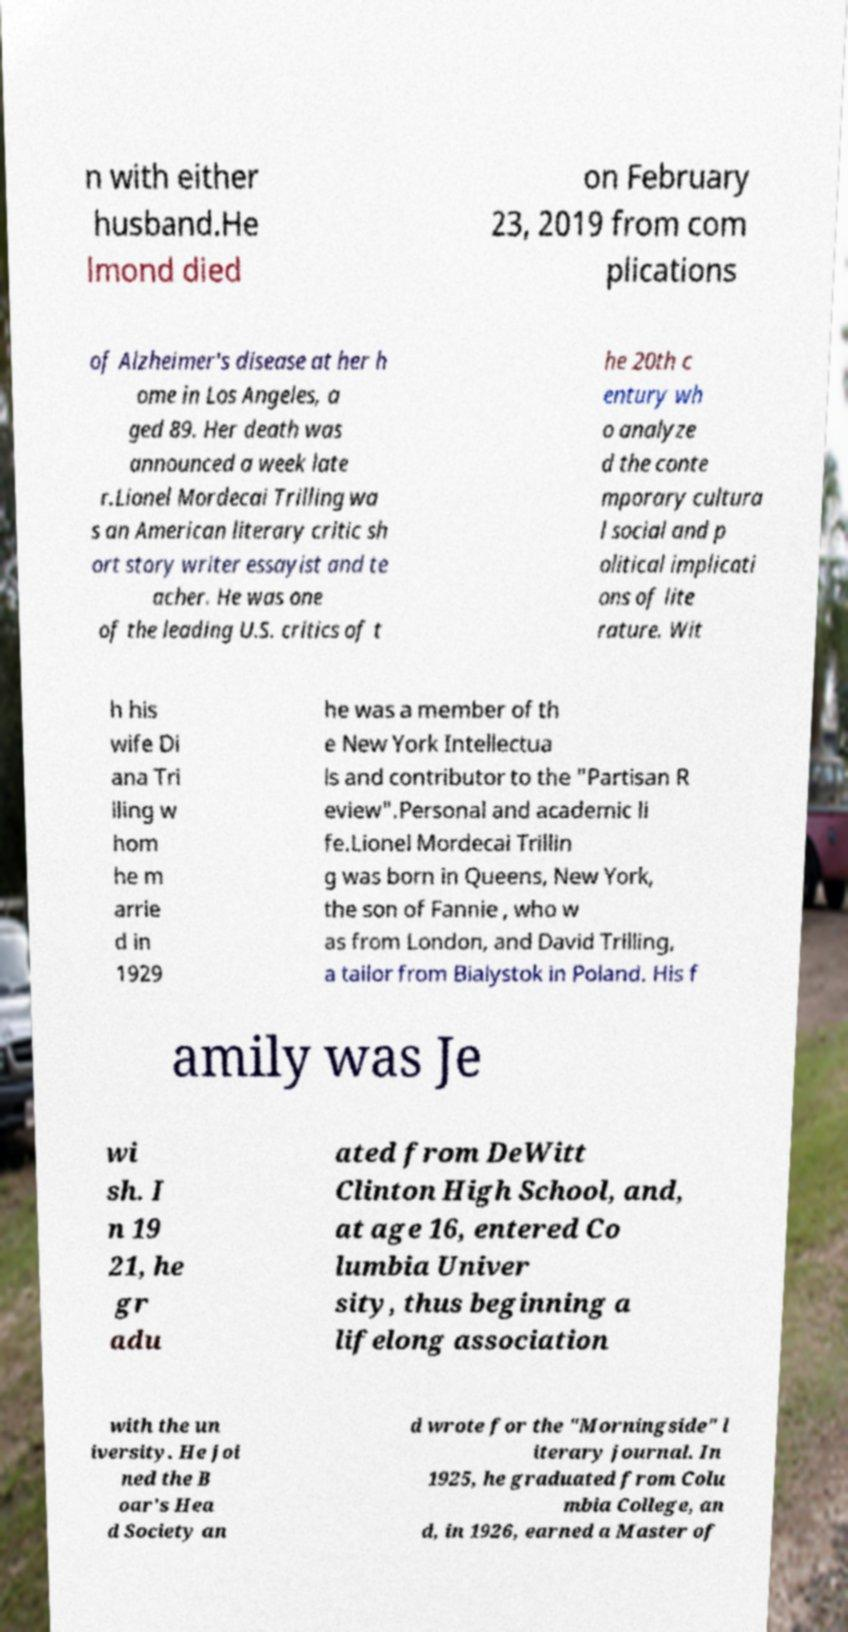There's text embedded in this image that I need extracted. Can you transcribe it verbatim? n with either husband.He lmond died on February 23, 2019 from com plications of Alzheimer's disease at her h ome in Los Angeles, a ged 89. Her death was announced a week late r.Lionel Mordecai Trilling wa s an American literary critic sh ort story writer essayist and te acher. He was one of the leading U.S. critics of t he 20th c entury wh o analyze d the conte mporary cultura l social and p olitical implicati ons of lite rature. Wit h his wife Di ana Tri lling w hom he m arrie d in 1929 he was a member of th e New York Intellectua ls and contributor to the "Partisan R eview".Personal and academic li fe.Lionel Mordecai Trillin g was born in Queens, New York, the son of Fannie , who w as from London, and David Trilling, a tailor from Bialystok in Poland. His f amily was Je wi sh. I n 19 21, he gr adu ated from DeWitt Clinton High School, and, at age 16, entered Co lumbia Univer sity, thus beginning a lifelong association with the un iversity. He joi ned the B oar's Hea d Society an d wrote for the "Morningside" l iterary journal. In 1925, he graduated from Colu mbia College, an d, in 1926, earned a Master of 